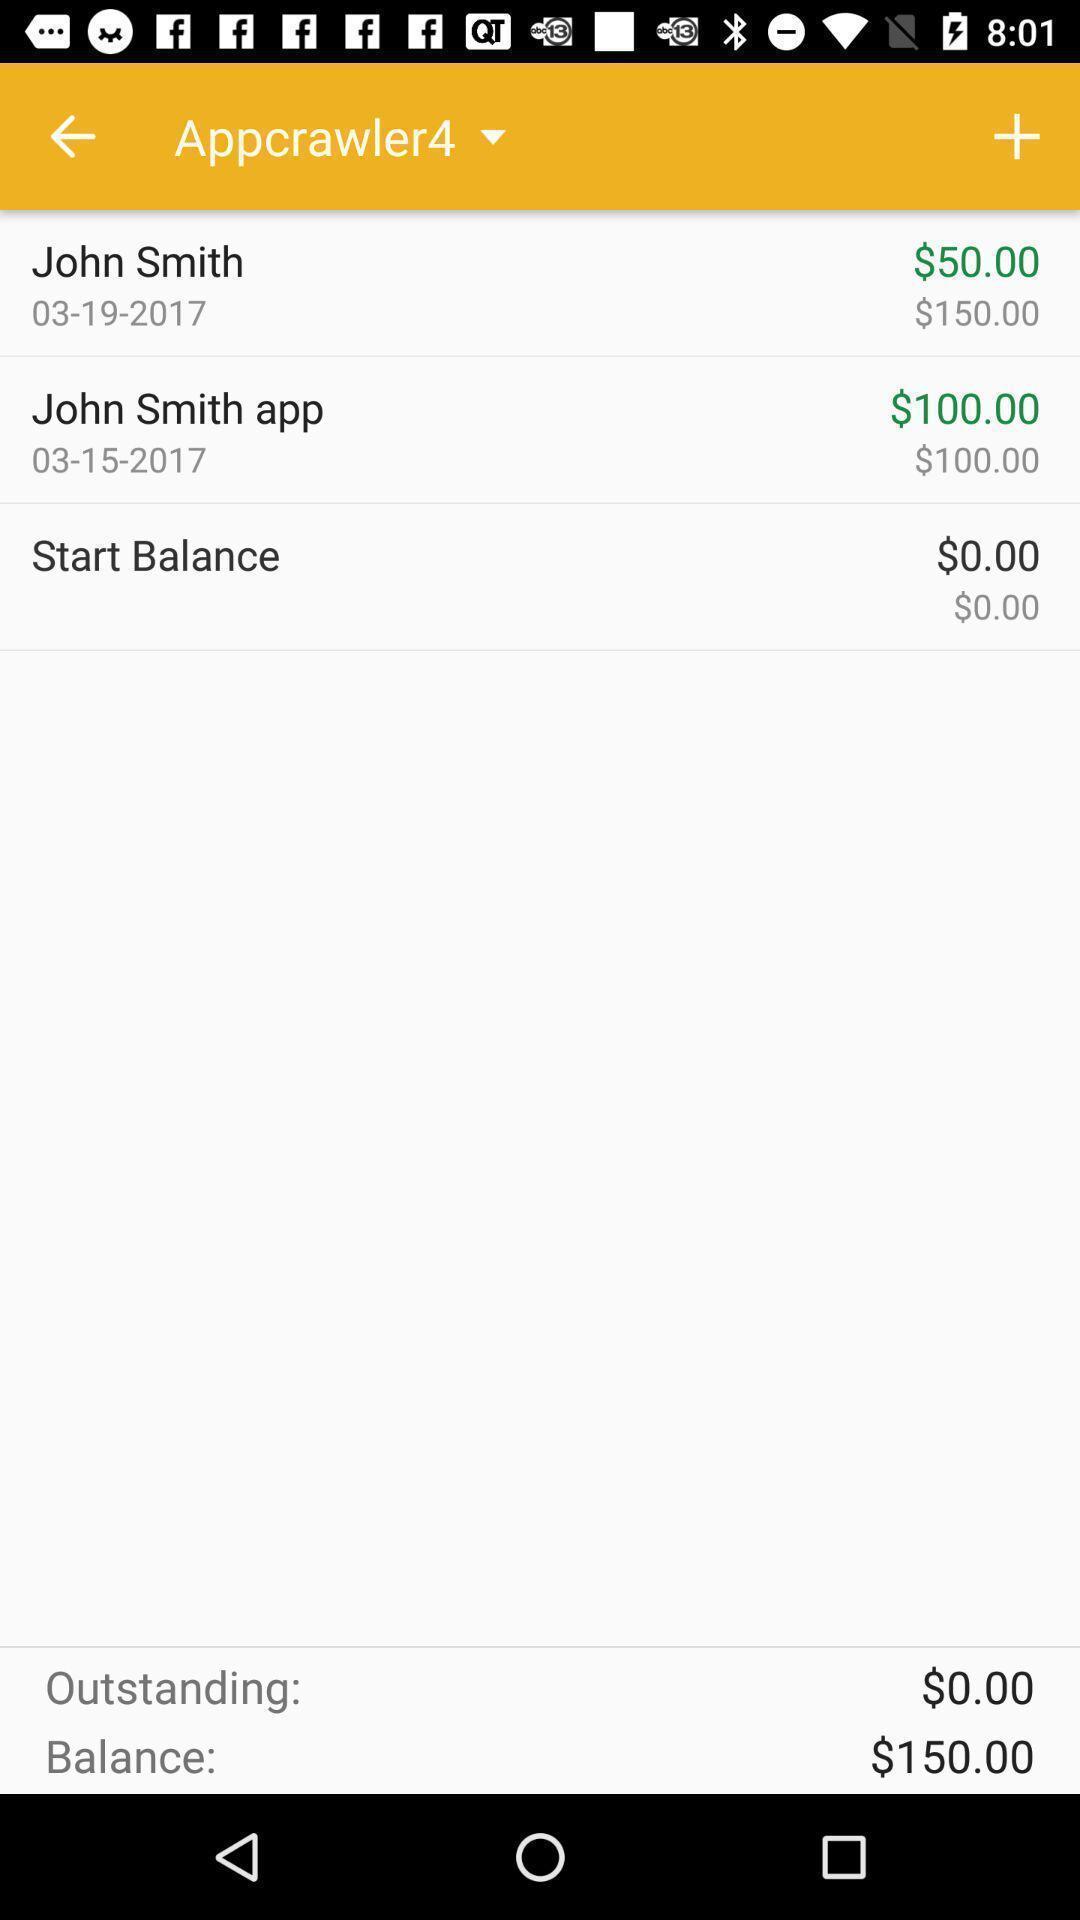Describe the content in this image. Page displaying with information in a financial application. 